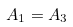<formula> <loc_0><loc_0><loc_500><loc_500>A _ { 1 } = A _ { 3 } \,</formula> 